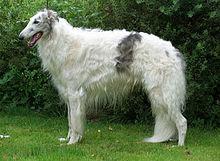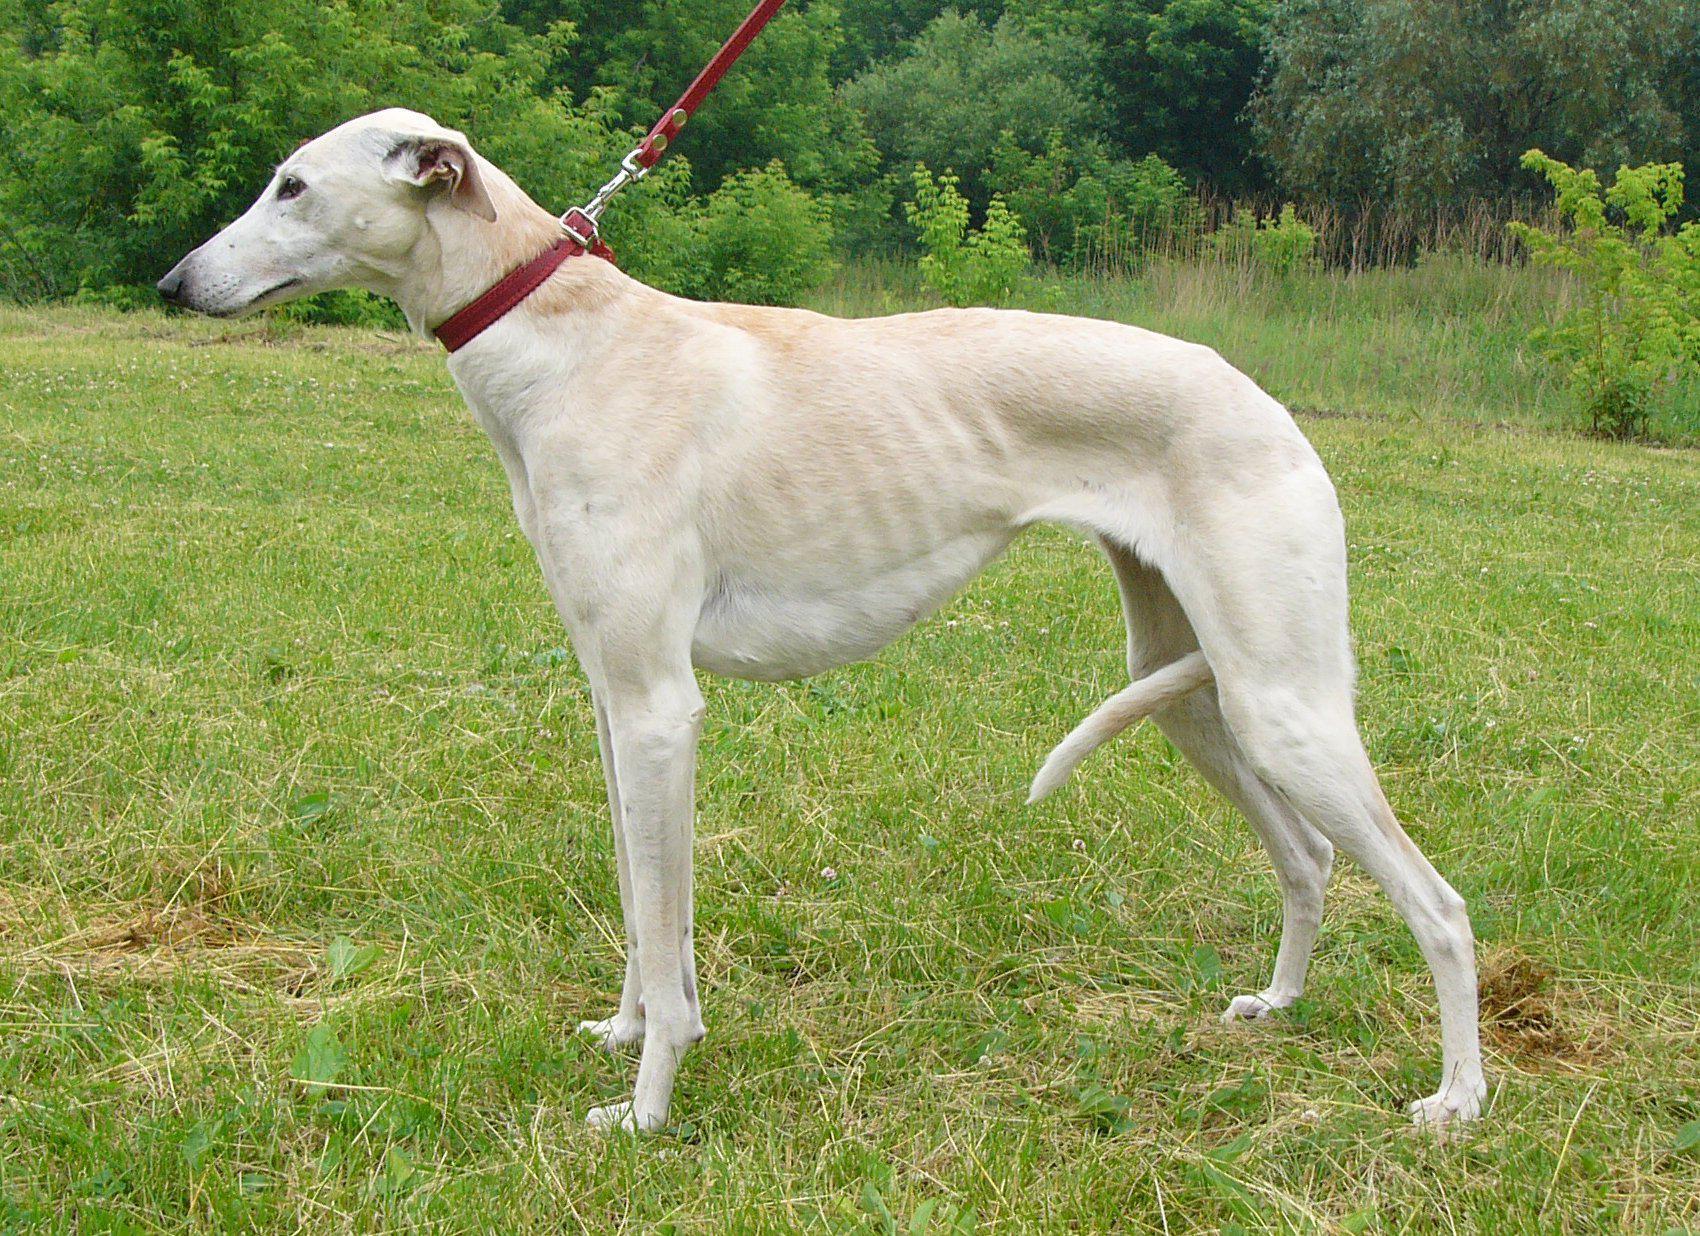The first image is the image on the left, the second image is the image on the right. Evaluate the accuracy of this statement regarding the images: "Each image shows one hound standing instead of walking.". Is it true? Answer yes or no. Yes. 